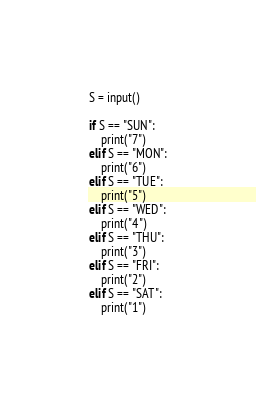Convert code to text. <code><loc_0><loc_0><loc_500><loc_500><_Python_>S = input()
 
if S == "SUN":
    print("7")
elif S == "MON":
    print("6")
elif S == "TUE":
    print("5")
elif S == "WED":
    print("4")
elif S == "THU":
    print("3")
elif S == "FRI":
    print("2")
elif S == "SAT":
    print("1")</code> 